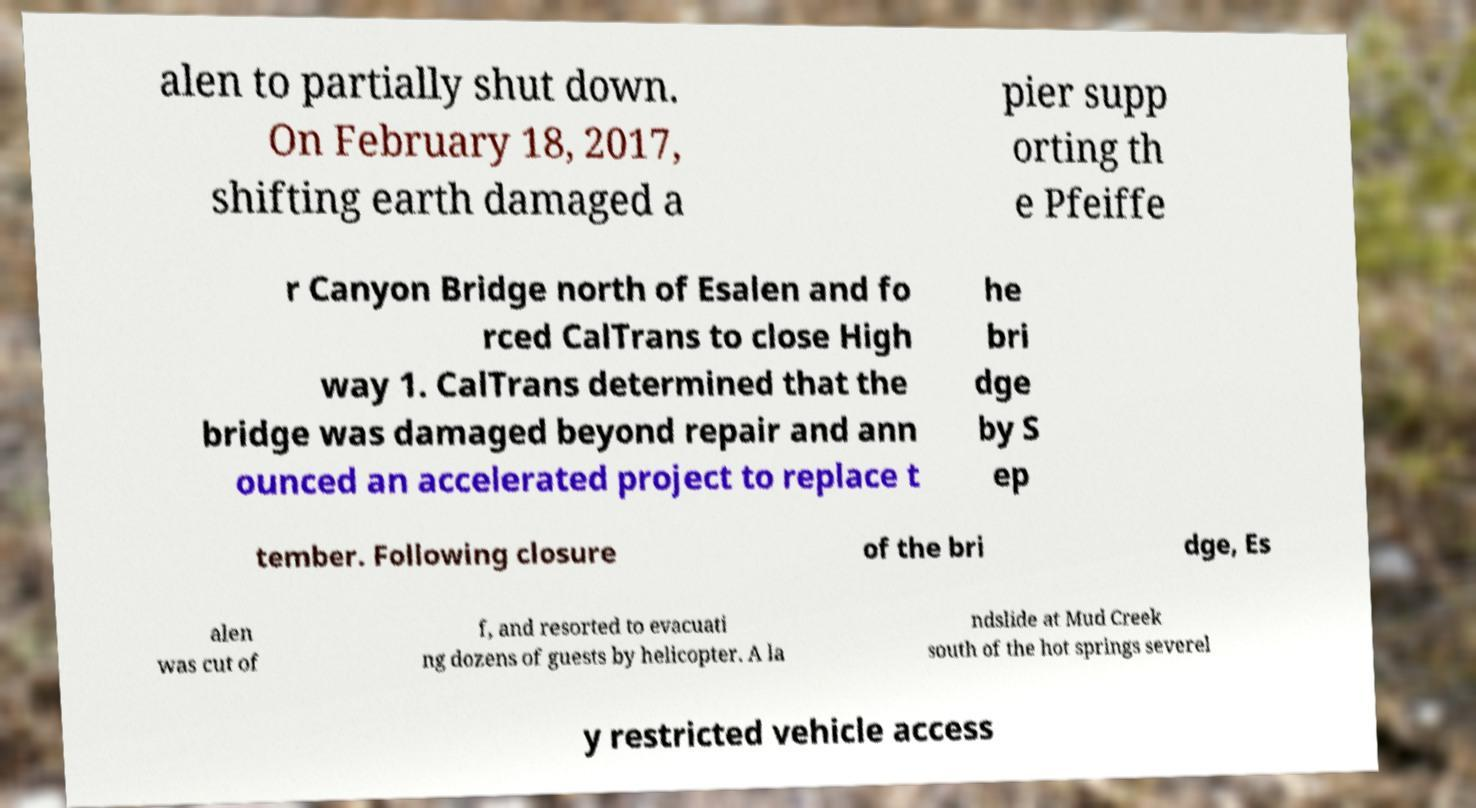There's text embedded in this image that I need extracted. Can you transcribe it verbatim? alen to partially shut down. On February 18, 2017, shifting earth damaged a pier supp orting th e Pfeiffe r Canyon Bridge north of Esalen and fo rced CalTrans to close High way 1. CalTrans determined that the bridge was damaged beyond repair and ann ounced an accelerated project to replace t he bri dge by S ep tember. Following closure of the bri dge, Es alen was cut of f, and resorted to evacuati ng dozens of guests by helicopter. A la ndslide at Mud Creek south of the hot springs severel y restricted vehicle access 